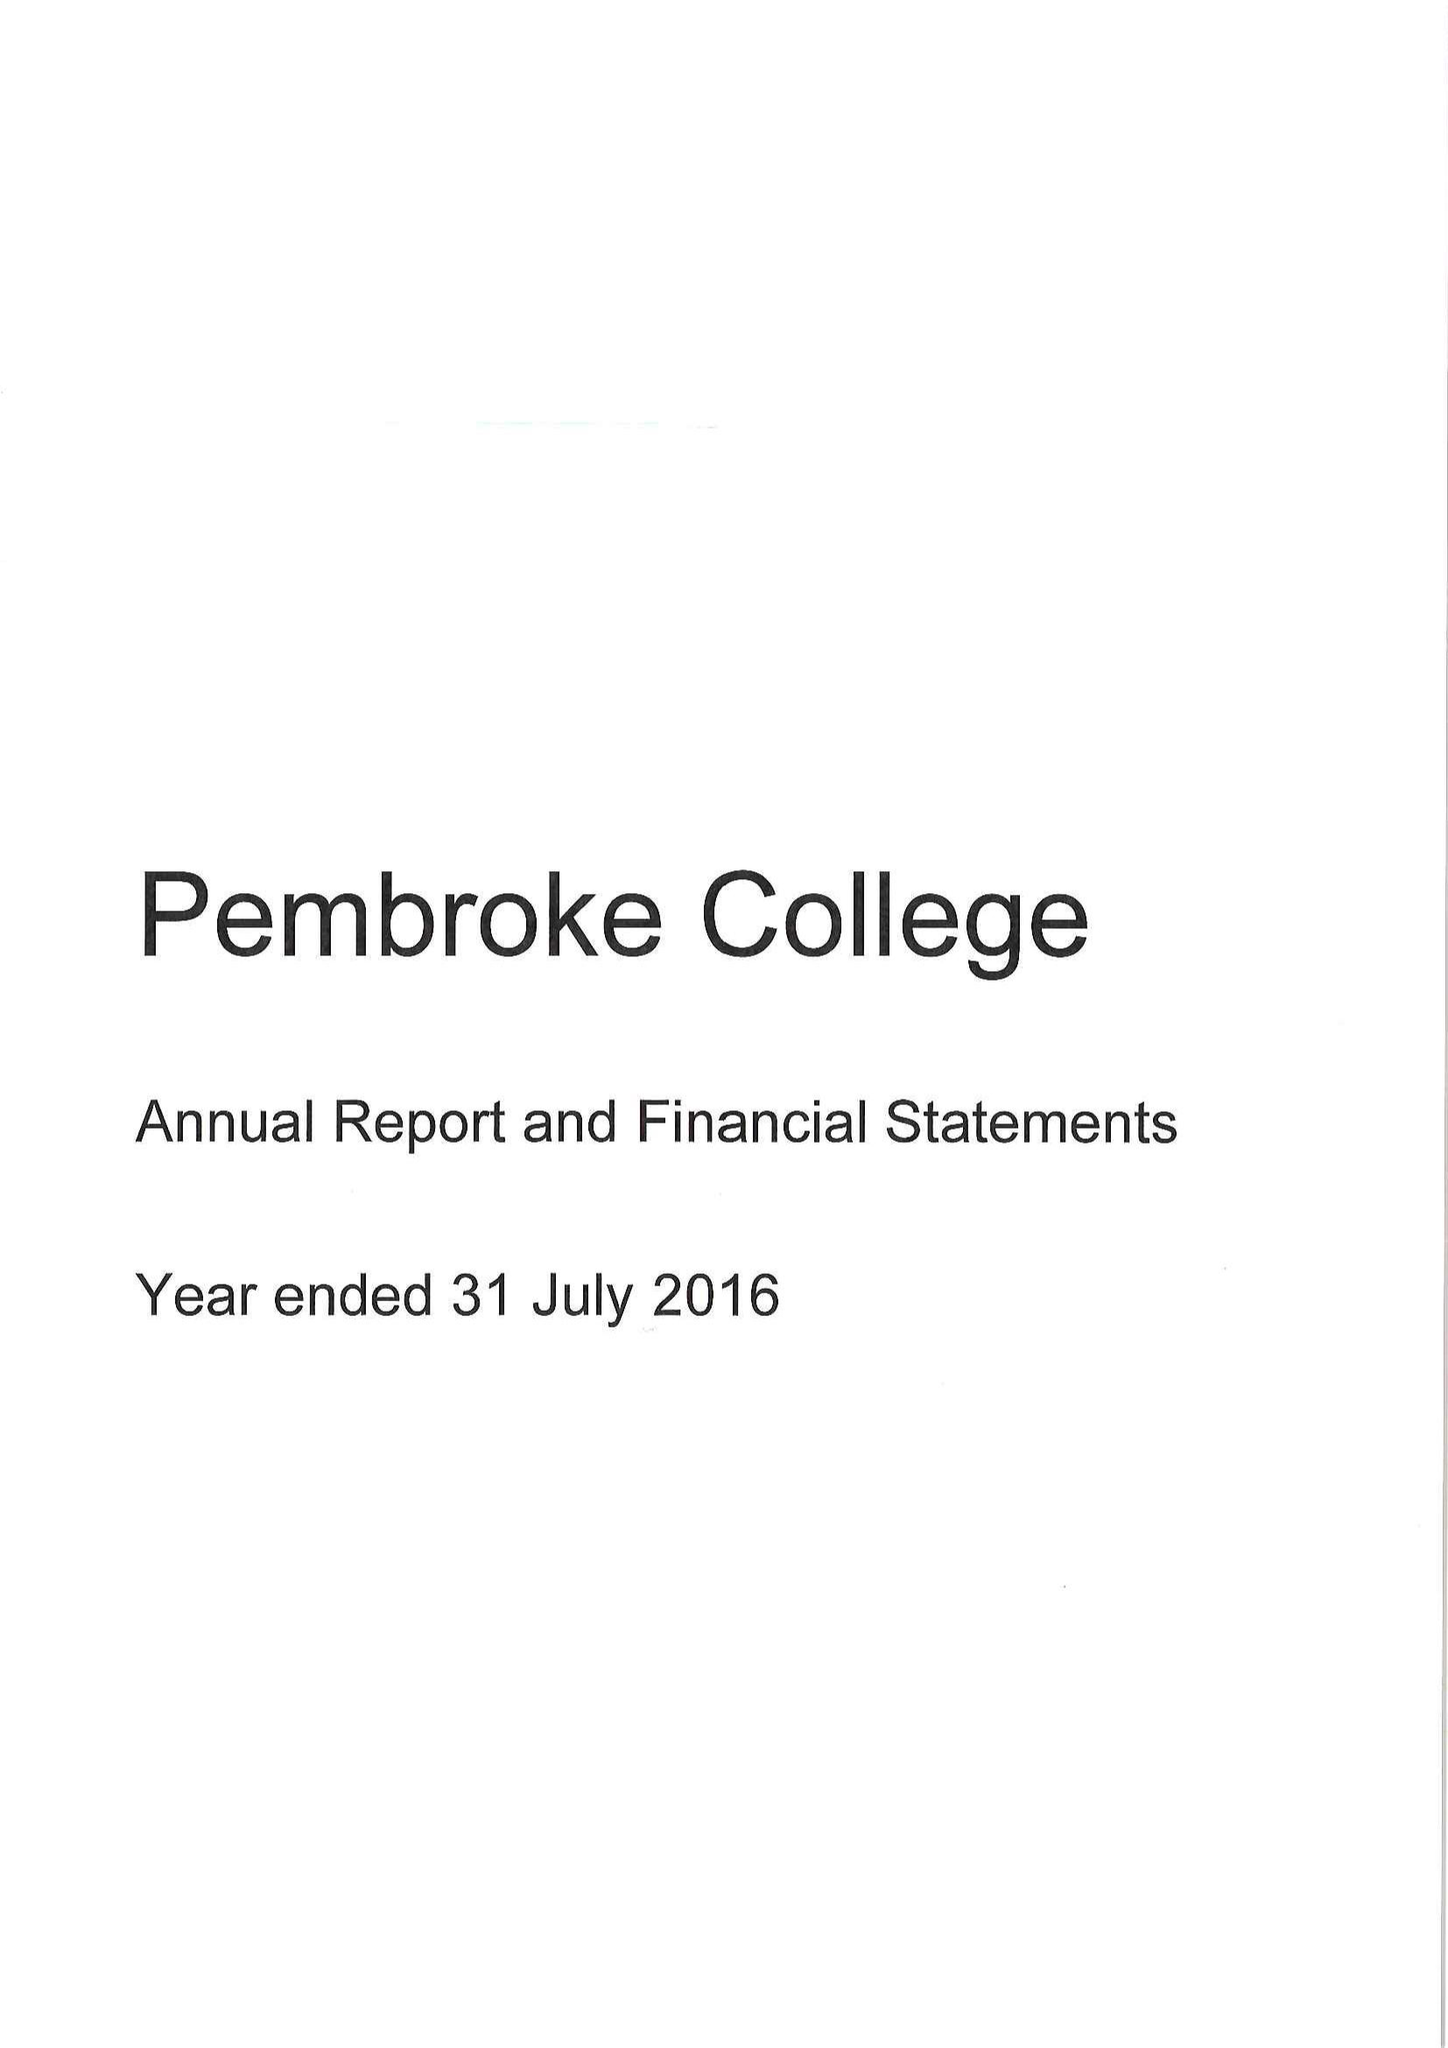What is the value for the charity_name?
Answer the question using a single word or phrase. Master Fellows and Scholars Of Pembroke College 